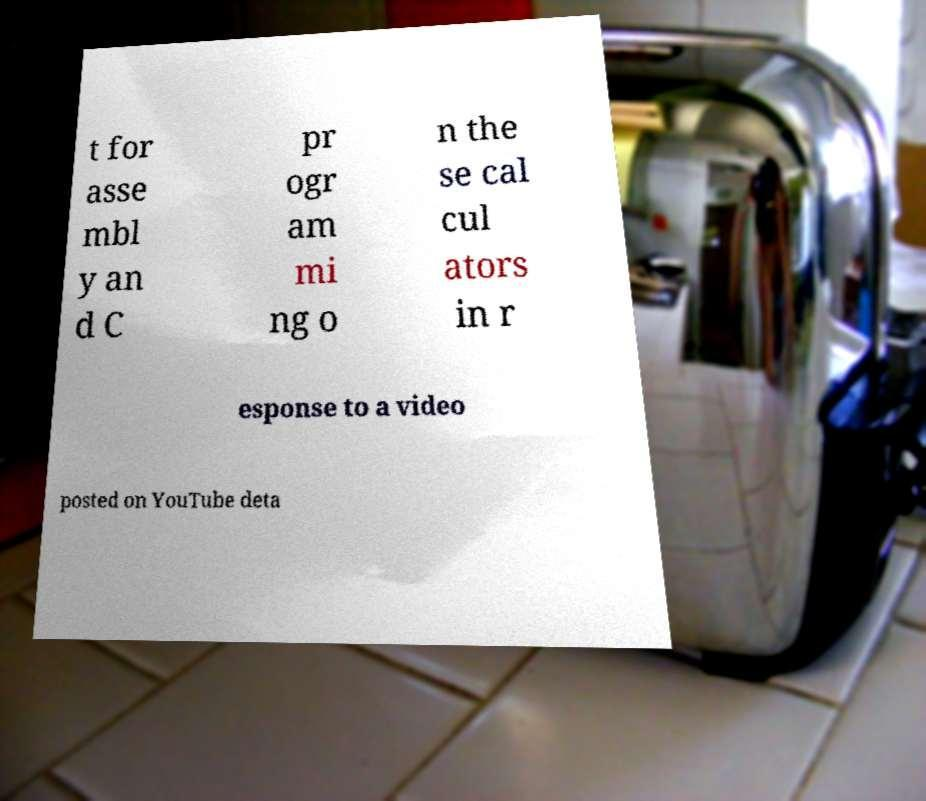Please identify and transcribe the text found in this image. t for asse mbl y an d C pr ogr am mi ng o n the se cal cul ators in r esponse to a video posted on YouTube deta 